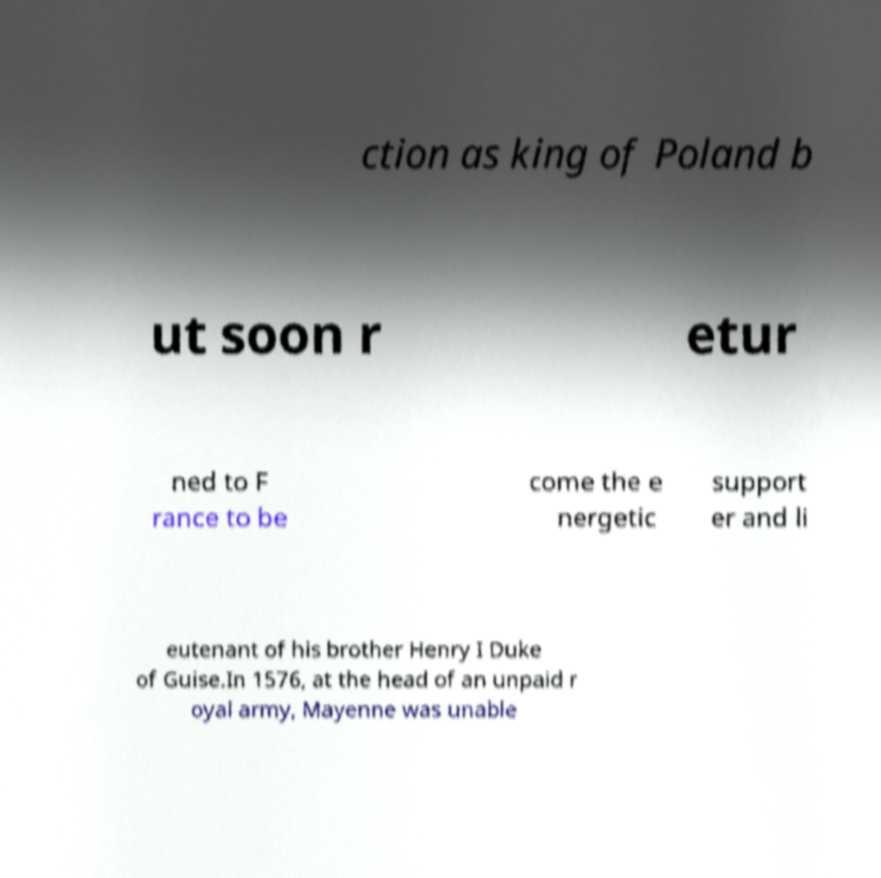What messages or text are displayed in this image? I need them in a readable, typed format. ction as king of Poland b ut soon r etur ned to F rance to be come the e nergetic support er and li eutenant of his brother Henry I Duke of Guise.In 1576, at the head of an unpaid r oyal army, Mayenne was unable 